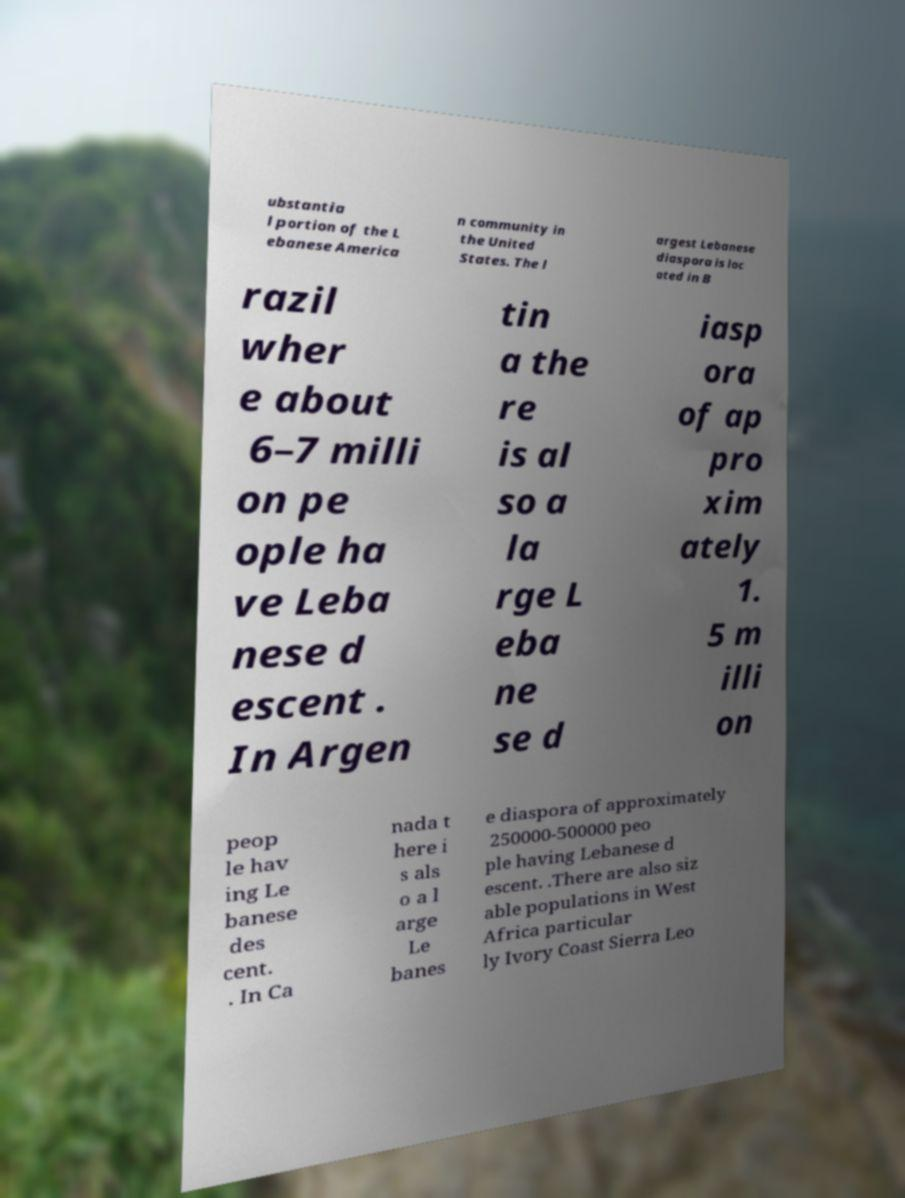Could you assist in decoding the text presented in this image and type it out clearly? ubstantia l portion of the L ebanese America n community in the United States. The l argest Lebanese diaspora is loc ated in B razil wher e about 6–7 milli on pe ople ha ve Leba nese d escent . In Argen tin a the re is al so a la rge L eba ne se d iasp ora of ap pro xim ately 1. 5 m illi on peop le hav ing Le banese des cent. . In Ca nada t here i s als o a l arge Le banes e diaspora of approximately 250000-500000 peo ple having Lebanese d escent. .There are also siz able populations in West Africa particular ly Ivory Coast Sierra Leo 